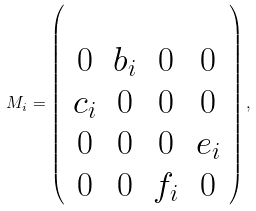Convert formula to latex. <formula><loc_0><loc_0><loc_500><loc_500>M _ { i } = \left ( \begin{array} { c c c c } \\ 0 & b _ { i } & 0 & 0 \\ c _ { i } & 0 & 0 & 0 \\ 0 & 0 & 0 & e _ { i } \\ 0 & 0 & f _ { i } & 0 \\ \end{array} \right ) ,</formula> 